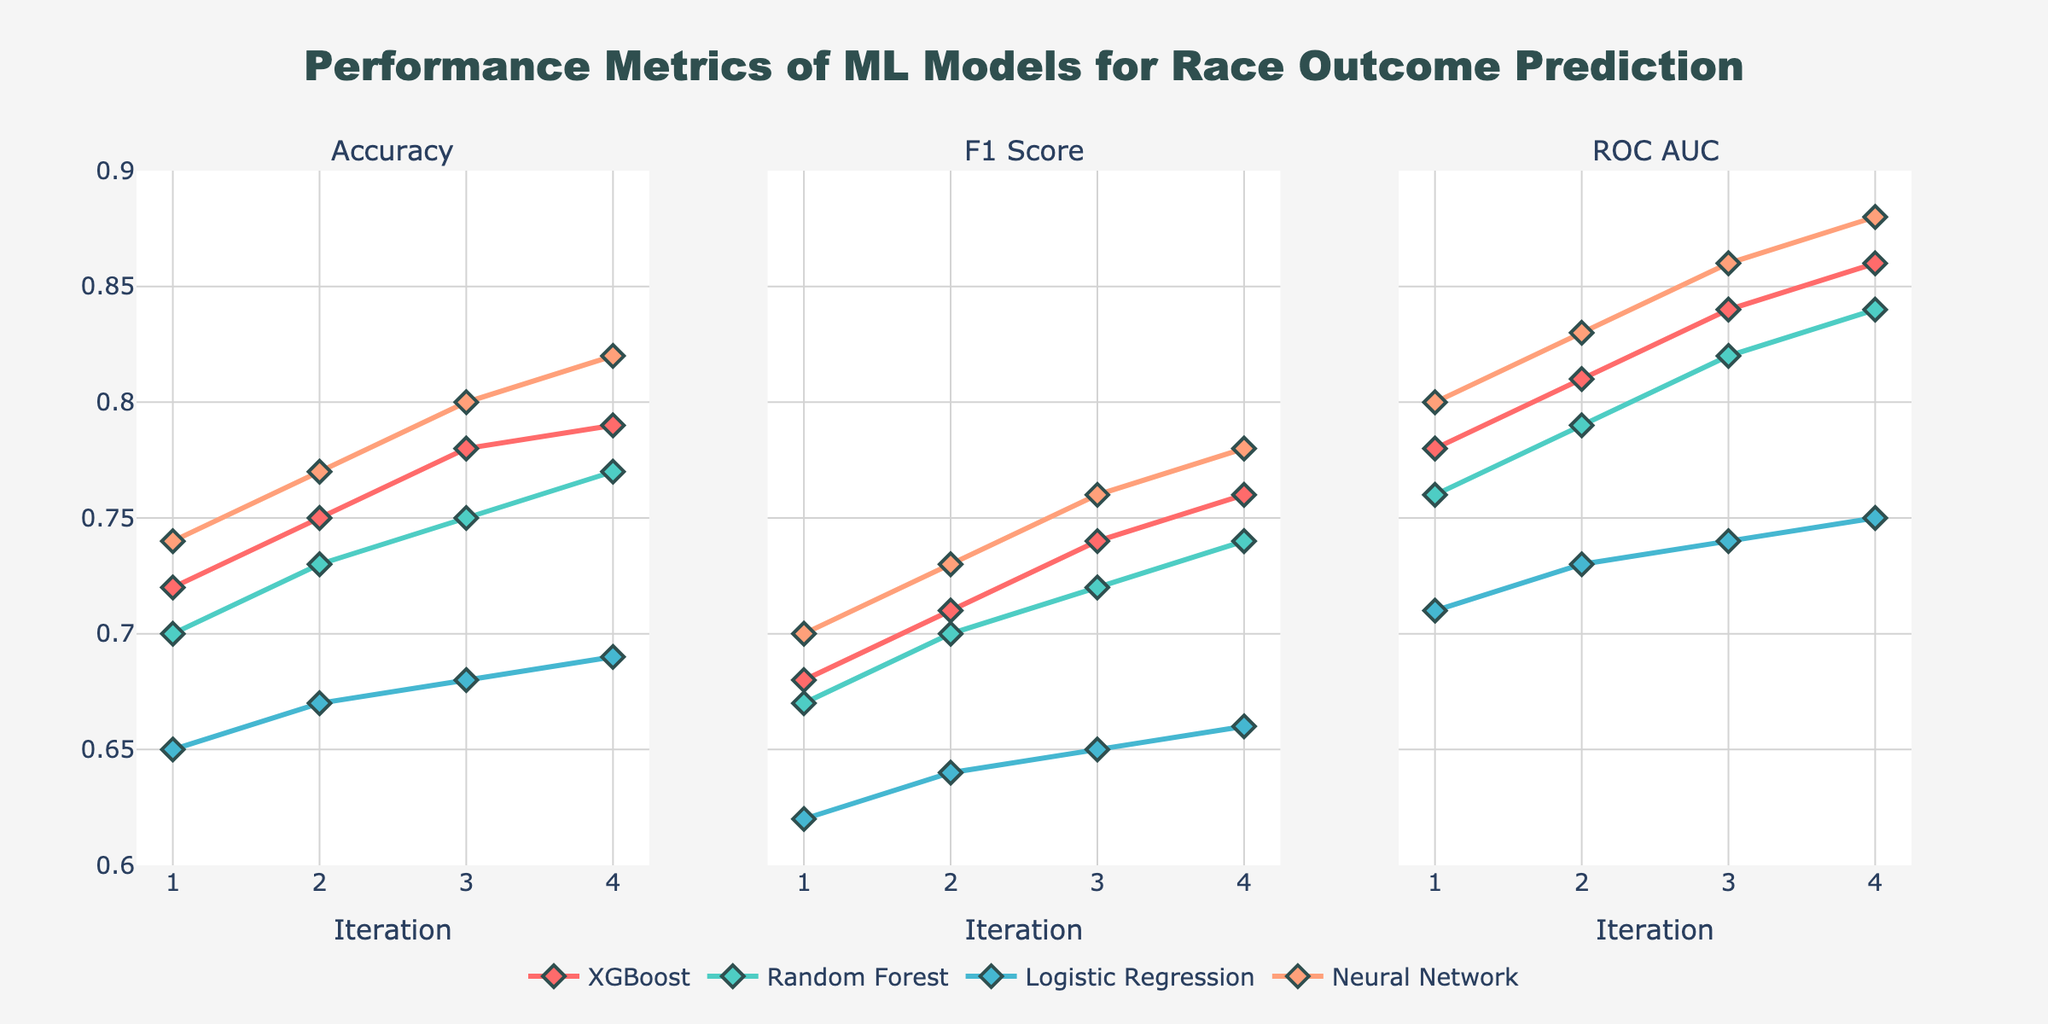What model shows the highest accuracy in the final iteration? Looking at the rightmost points on the "Accuracy" subplot, we identify that Neural Network reaches the highest point among all models.
Answer: Neural Network Which model's F1 Score increased the most from the first to the last iteration? To find this, observe the F1 Score subplot and calculate the difference between the F1 Score at iteration 4 and iteration 1 for each model. Neural Network increased from 0.70 to 0.78, an increase of 0.08, which is the largest compared to other models.
Answer: Neural Network How does the ROC AUC score of XGBoost in the third iteration compare to that of the Random Forest in the same iteration? On the "ROC AUC" subplot at iteration 3, XGBoost has 0.84 and Random Forest has 0.82. Therefore, XGBoost's ROC AUC score is higher than Random Forest's.
Answer: XGBoost's ROC AUC is higher What is the trend in accuracy for Neural Networks across iterations? By observing the "Accuracy" subplot, we see that the accuracy for Neural Networks increases progressively from iteration 1 to iteration 4, going from 0.74 to 0.82.
Answer: Increasing trend Which model had the lowest F1 Score in the first iteration and what was that score? Checking the "F1 Score" subplot at iteration 1, Logistic Regression has the lowest F1 Score among all the models, which is 0.62.
Answer: Logistic Regression with 0.62 On which iteration do all models have an ROC AUC above 0.80? Examining the "ROC AUC" subplot, it is clear that by iteration 3, all models have their ROC AUC scores above 0.80.
Answer: Iteration 3 Which model shows the smallest improvement in accuracy from the first to the last iteration? By observing the initial and final points on the "Accuracy" subplot for all models, Logistic Regression shows the smallest increase, from 0.65 to 0.69, which is an increase of 0.04.
Answer: Logistic Regression 